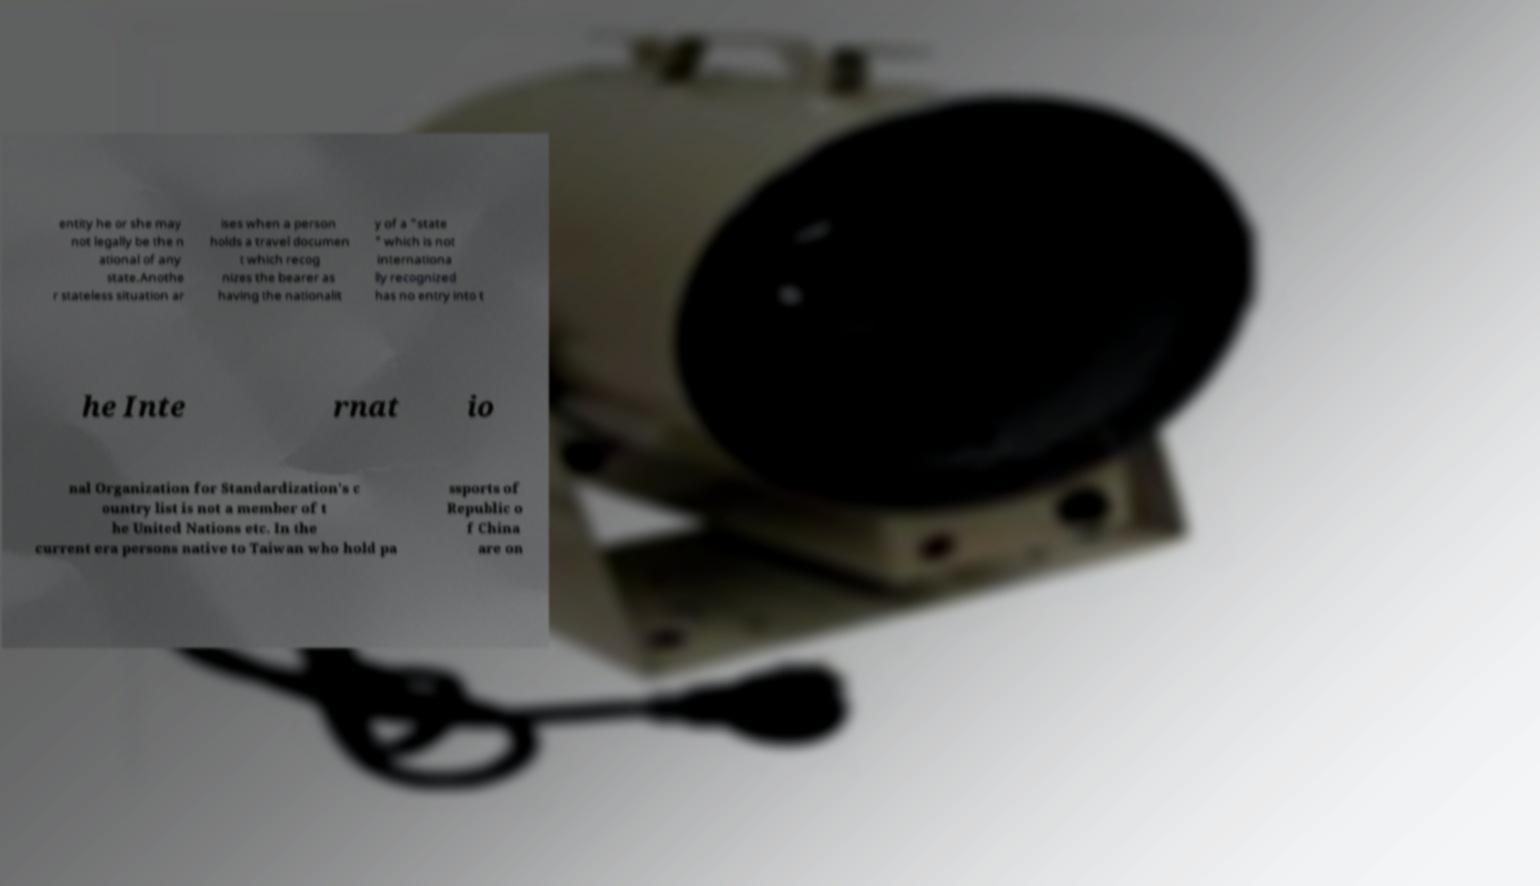What messages or text are displayed in this image? I need them in a readable, typed format. entity he or she may not legally be the n ational of any state.Anothe r stateless situation ar ises when a person holds a travel documen t which recog nizes the bearer as having the nationalit y of a "state " which is not internationa lly recognized has no entry into t he Inte rnat io nal Organization for Standardization's c ountry list is not a member of t he United Nations etc. In the current era persons native to Taiwan who hold pa ssports of Republic o f China are on 